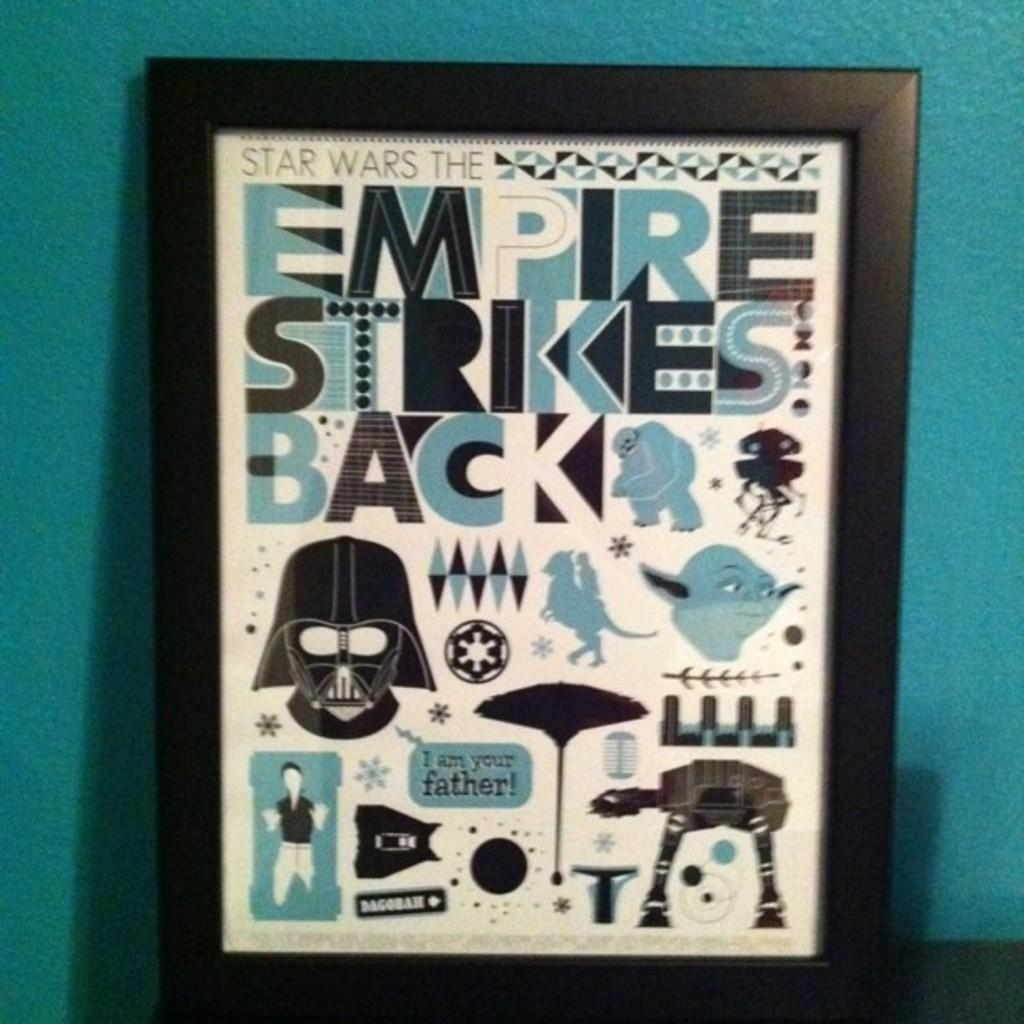<image>
Present a compact description of the photo's key features. The picture shown is for a star wars fan I am your father! 